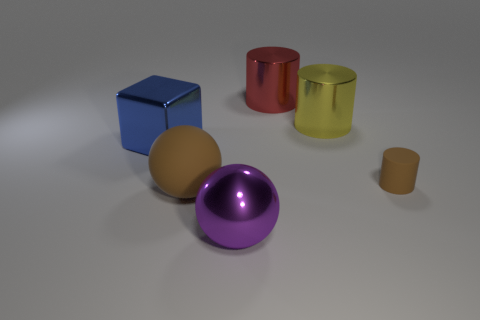What is the relationship between the size of the objects and their proximity to the center of the image? Intriguing observation! The objects in the center of the image tend to be larger in size compared to those positioned nearer to the edges. The purple sphere and the yellow ball are quite dominant and central, while the smaller objects, like the miniature yellow cylinder and the brown sphere, are closer to the periphery. 